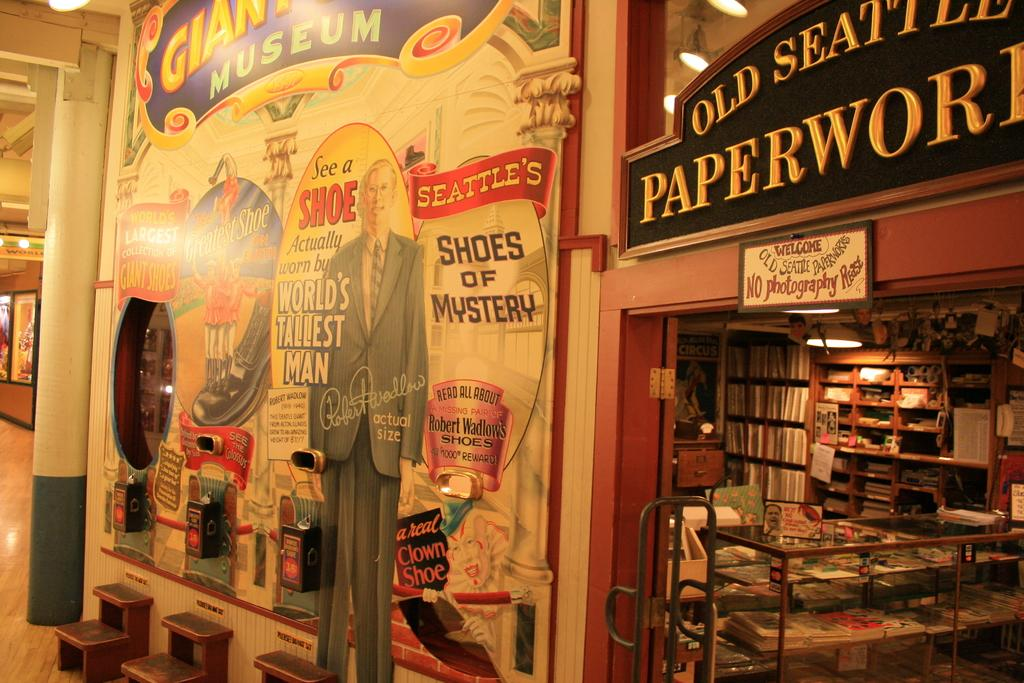<image>
Create a compact narrative representing the image presented. Old Seattle Paperworld store front with old time feel 